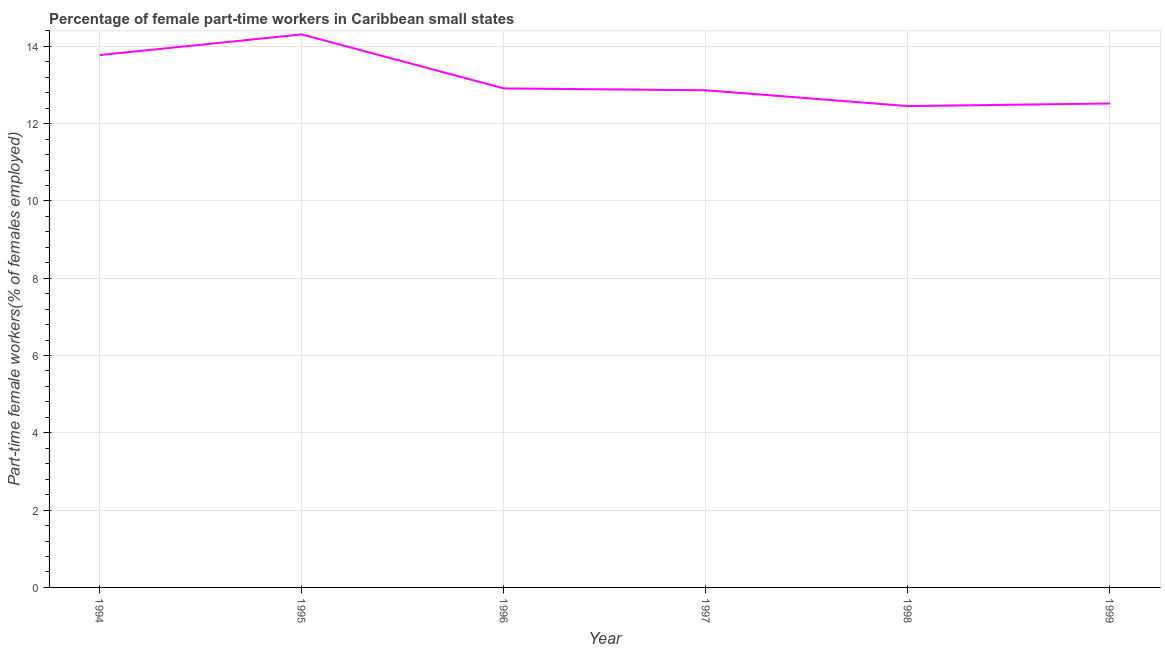What is the percentage of part-time female workers in 1994?
Your response must be concise. 13.77. Across all years, what is the maximum percentage of part-time female workers?
Your answer should be compact. 14.31. Across all years, what is the minimum percentage of part-time female workers?
Give a very brief answer. 12.45. In which year was the percentage of part-time female workers minimum?
Ensure brevity in your answer.  1998. What is the sum of the percentage of part-time female workers?
Keep it short and to the point. 78.83. What is the difference between the percentage of part-time female workers in 1995 and 1996?
Offer a very short reply. 1.4. What is the average percentage of part-time female workers per year?
Make the answer very short. 13.14. What is the median percentage of part-time female workers?
Your response must be concise. 12.89. Do a majority of the years between 1998 and 1997 (inclusive) have percentage of part-time female workers greater than 8.4 %?
Give a very brief answer. No. What is the ratio of the percentage of part-time female workers in 1995 to that in 1997?
Keep it short and to the point. 1.11. Is the difference between the percentage of part-time female workers in 1998 and 1999 greater than the difference between any two years?
Your response must be concise. No. What is the difference between the highest and the second highest percentage of part-time female workers?
Make the answer very short. 0.53. What is the difference between the highest and the lowest percentage of part-time female workers?
Offer a very short reply. 1.85. How many lines are there?
Your answer should be very brief. 1. Are the values on the major ticks of Y-axis written in scientific E-notation?
Your answer should be very brief. No. Does the graph contain grids?
Ensure brevity in your answer.  Yes. What is the title of the graph?
Offer a very short reply. Percentage of female part-time workers in Caribbean small states. What is the label or title of the X-axis?
Offer a terse response. Year. What is the label or title of the Y-axis?
Your answer should be very brief. Part-time female workers(% of females employed). What is the Part-time female workers(% of females employed) in 1994?
Offer a terse response. 13.77. What is the Part-time female workers(% of females employed) in 1995?
Ensure brevity in your answer.  14.31. What is the Part-time female workers(% of females employed) in 1996?
Keep it short and to the point. 12.91. What is the Part-time female workers(% of females employed) in 1997?
Keep it short and to the point. 12.86. What is the Part-time female workers(% of females employed) in 1998?
Keep it short and to the point. 12.45. What is the Part-time female workers(% of females employed) in 1999?
Keep it short and to the point. 12.52. What is the difference between the Part-time female workers(% of females employed) in 1994 and 1995?
Offer a very short reply. -0.53. What is the difference between the Part-time female workers(% of females employed) in 1994 and 1996?
Your answer should be compact. 0.86. What is the difference between the Part-time female workers(% of females employed) in 1994 and 1997?
Give a very brief answer. 0.91. What is the difference between the Part-time female workers(% of females employed) in 1994 and 1998?
Make the answer very short. 1.32. What is the difference between the Part-time female workers(% of females employed) in 1994 and 1999?
Your answer should be very brief. 1.25. What is the difference between the Part-time female workers(% of females employed) in 1995 and 1996?
Provide a succinct answer. 1.4. What is the difference between the Part-time female workers(% of females employed) in 1995 and 1997?
Offer a very short reply. 1.45. What is the difference between the Part-time female workers(% of females employed) in 1995 and 1998?
Keep it short and to the point. 1.85. What is the difference between the Part-time female workers(% of females employed) in 1995 and 1999?
Your answer should be compact. 1.79. What is the difference between the Part-time female workers(% of females employed) in 1996 and 1997?
Make the answer very short. 0.05. What is the difference between the Part-time female workers(% of females employed) in 1996 and 1998?
Provide a short and direct response. 0.46. What is the difference between the Part-time female workers(% of females employed) in 1996 and 1999?
Provide a short and direct response. 0.39. What is the difference between the Part-time female workers(% of females employed) in 1997 and 1998?
Provide a succinct answer. 0.41. What is the difference between the Part-time female workers(% of females employed) in 1997 and 1999?
Give a very brief answer. 0.34. What is the difference between the Part-time female workers(% of females employed) in 1998 and 1999?
Offer a very short reply. -0.07. What is the ratio of the Part-time female workers(% of females employed) in 1994 to that in 1996?
Make the answer very short. 1.07. What is the ratio of the Part-time female workers(% of females employed) in 1994 to that in 1997?
Keep it short and to the point. 1.07. What is the ratio of the Part-time female workers(% of females employed) in 1994 to that in 1998?
Your answer should be compact. 1.11. What is the ratio of the Part-time female workers(% of females employed) in 1995 to that in 1996?
Ensure brevity in your answer.  1.11. What is the ratio of the Part-time female workers(% of females employed) in 1995 to that in 1997?
Make the answer very short. 1.11. What is the ratio of the Part-time female workers(% of females employed) in 1995 to that in 1998?
Your answer should be compact. 1.15. What is the ratio of the Part-time female workers(% of females employed) in 1995 to that in 1999?
Make the answer very short. 1.14. What is the ratio of the Part-time female workers(% of females employed) in 1996 to that in 1998?
Provide a short and direct response. 1.04. What is the ratio of the Part-time female workers(% of females employed) in 1996 to that in 1999?
Make the answer very short. 1.03. What is the ratio of the Part-time female workers(% of females employed) in 1997 to that in 1998?
Ensure brevity in your answer.  1.03. What is the ratio of the Part-time female workers(% of females employed) in 1997 to that in 1999?
Offer a very short reply. 1.03. 